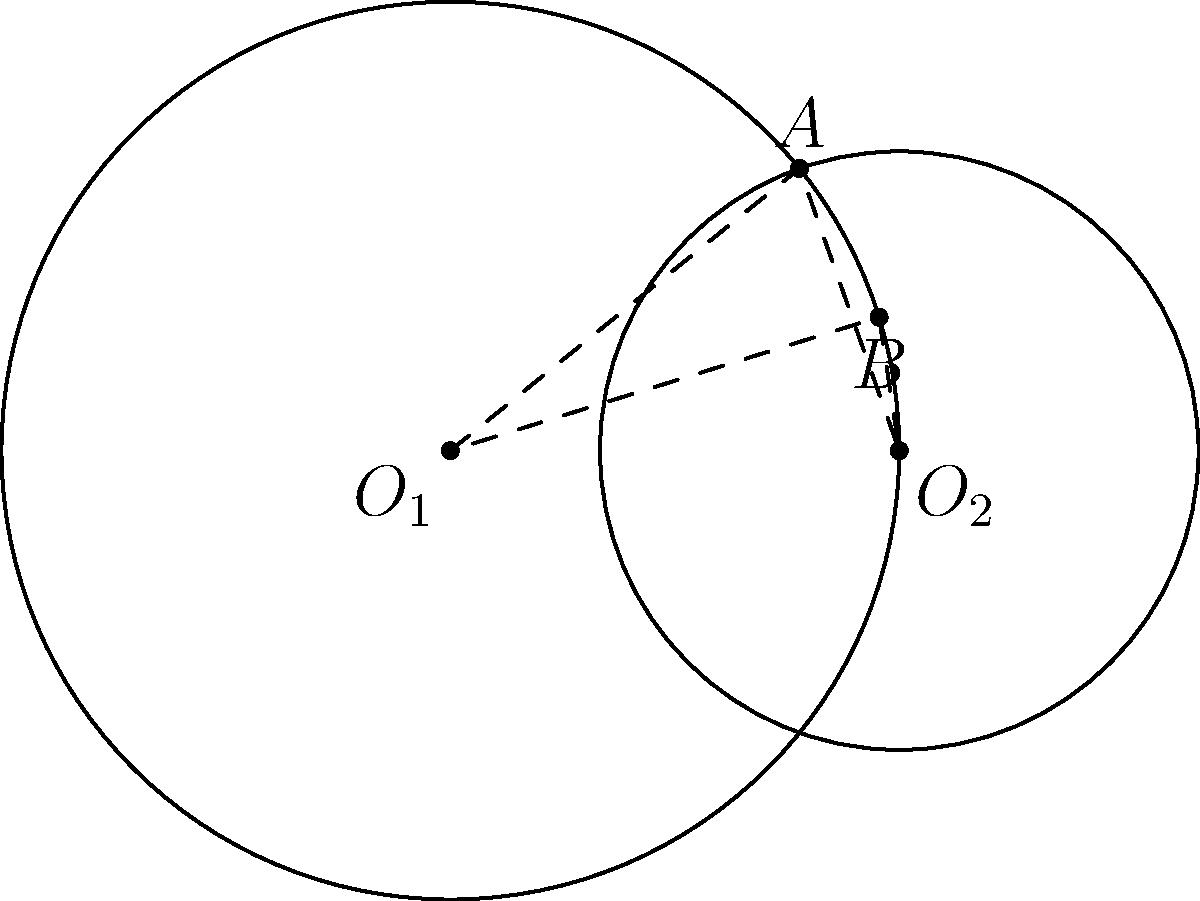In a classic tale of two overlapping realms, consider two circles with centers $O_1$ and $O_2$. The distance between their centers is 3 units. The radius of the circle centered at $O_1$ is 3 units, while the radius of the circle centered at $O_2$ is 2 units. What is the area of the quadrilateral formed by connecting the two centers and the two intersection points of the circles? Let's approach this step-by-step, as if crafting a well-structured narrative:

1) First, we identify the key elements of our story: two circles and their intersection points. Let's call the intersection points A and B.

2) The quadrilateral formed is $O_1AO_2B$. To find its area, we can split it into two triangles: $O_1AO_2$ and $O_1BO_2$.

3) These triangles are congruent due to the symmetry of the situation. So, we only need to calculate the area of one triangle and double it.

4) To find the area of triangle $O_1AO_2$, we can use Heron's formula. But first, we need the length of $AO_2$.

5) We can find $AO_2$ using the Pythagorean theorem in triangle $O_1AO_2$:

   $AO_2^2 = O_1O_2^2 + O_1A^2 - 2(O_1O_2)(O_1A)\cos(\angle AO_1O_2)$

6) We know $O_1O_2 = 3$, $O_1A = 3$, and $O_2A = 2$. We can find $\cos(\angle AO_1O_2)$ using the cosine law:

   $\cos(\angle AO_1O_2) = \frac{O_1O_2^2 + O_1A^2 - O_2A^2}{2(O_1O_2)(O_1A)} = \frac{3^2 + 3^2 - 2^2}{2(3)(3)} = \frac{5}{6}$

7) Substituting into the equation from step 5:

   $AO_2^2 = 3^2 + 3^2 - 2(3)(3)(\frac{5}{6}) = 18 - 15 = 3$

   So, $AO_2 = \sqrt{3}$

8) Now we have all sides of triangle $O_1AO_2$: 3, 3, and $\sqrt{3}$. We can use Heron's formula:

   $s = \frac{3 + 3 + \sqrt{3}}{2} = \frac{6 + \sqrt{3}}{2}$

   $Area = \sqrt{s(s-3)(s-3)(s-\sqrt{3})}$

9) Calculating this and doubling for the full quadrilateral:

   $Area_{quadrilateral} = 2\sqrt{s(s-3)(s-3)(s-\sqrt{3})} = 2\sqrt{\frac{6 + \sqrt{3}}{2}(\frac{\sqrt{3}}{2})(\frac{\sqrt{3}}{2})(\frac{6 - \sqrt{3}}{2})}$

10) Simplifying: $Area_{quadrilateral} = 3\sqrt{3}$
Answer: $3\sqrt{3}$ square units 